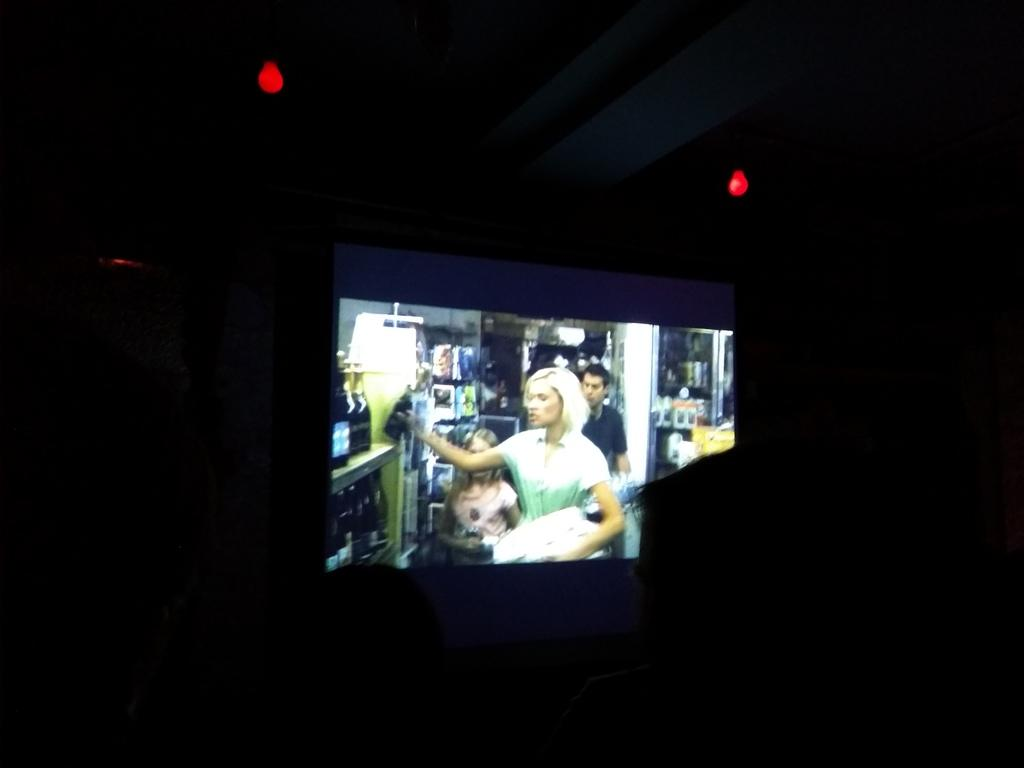What is the main object in the image? There is a projector in the image. What are the two objects on top of the projector? There are two bulbs on top of the projector. What can be seen behind the projector? There is a wall visible in the image. What is the purpose of the trains in the image? There are no trains present in the image, so it is not possible to determine their purpose. 